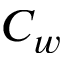Convert formula to latex. <formula><loc_0><loc_0><loc_500><loc_500>C _ { w }</formula> 